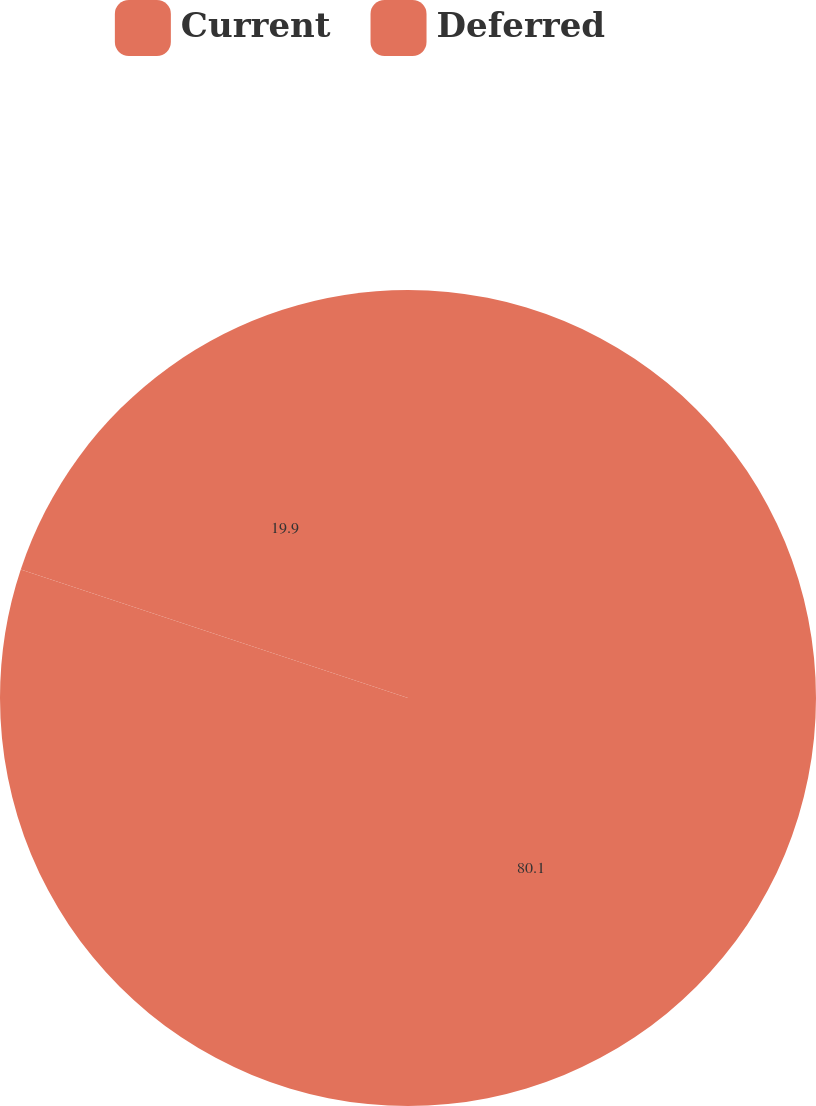Convert chart to OTSL. <chart><loc_0><loc_0><loc_500><loc_500><pie_chart><fcel>Current<fcel>Deferred<nl><fcel>80.1%<fcel>19.9%<nl></chart> 